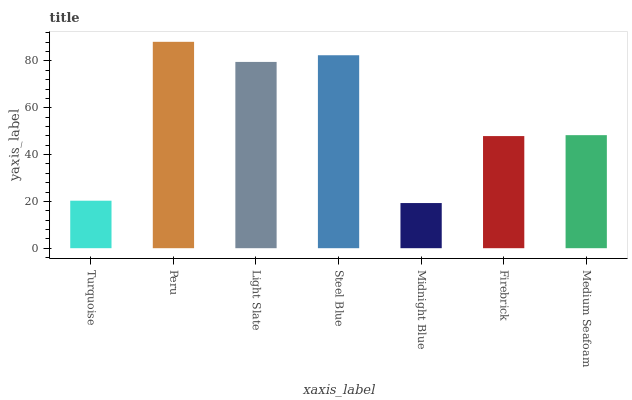Is Midnight Blue the minimum?
Answer yes or no. Yes. Is Peru the maximum?
Answer yes or no. Yes. Is Light Slate the minimum?
Answer yes or no. No. Is Light Slate the maximum?
Answer yes or no. No. Is Peru greater than Light Slate?
Answer yes or no. Yes. Is Light Slate less than Peru?
Answer yes or no. Yes. Is Light Slate greater than Peru?
Answer yes or no. No. Is Peru less than Light Slate?
Answer yes or no. No. Is Medium Seafoam the high median?
Answer yes or no. Yes. Is Medium Seafoam the low median?
Answer yes or no. Yes. Is Steel Blue the high median?
Answer yes or no. No. Is Light Slate the low median?
Answer yes or no. No. 